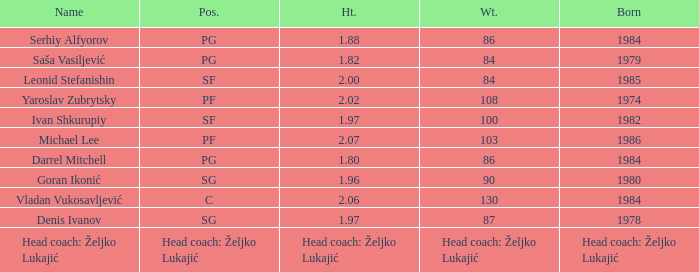Which position did Michael Lee play? PF. 